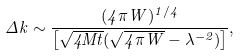<formula> <loc_0><loc_0><loc_500><loc_500>\Delta k \sim \frac { ( 4 \pi W ) ^ { 1 / 4 } } { \left [ \sqrt { 4 M t } ( \sqrt { 4 \pi W } - \lambda ^ { - 2 } ) \right ] } ,</formula> 